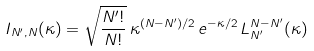Convert formula to latex. <formula><loc_0><loc_0><loc_500><loc_500>I _ { N ^ { \prime } , N } ( \kappa ) = \sqrt { \frac { N ^ { \prime } ! } { N ! } } \, \kappa ^ { ( N - N ^ { \prime } ) / 2 } \, e ^ { - \kappa / 2 } \, L _ { N ^ { \prime } } ^ { N - N ^ { \prime } } ( \kappa )</formula> 